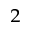<formula> <loc_0><loc_0><loc_500><loc_500>_ { 2 }</formula> 